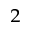<formula> <loc_0><loc_0><loc_500><loc_500>_ { 2 }</formula> 